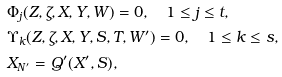<formula> <loc_0><loc_0><loc_500><loc_500>& \Phi _ { j } ( Z , \zeta , X , Y , W ) = 0 , \quad 1 \leq j \leq t , \\ & \Upsilon _ { k } ( Z , \zeta , X , Y , S , T , W ^ { \prime } ) = 0 , \quad 1 \leq k \leq s , \\ & X _ { N ^ { \prime } } = Q ^ { \prime } ( X ^ { \prime } , S ) ,</formula> 